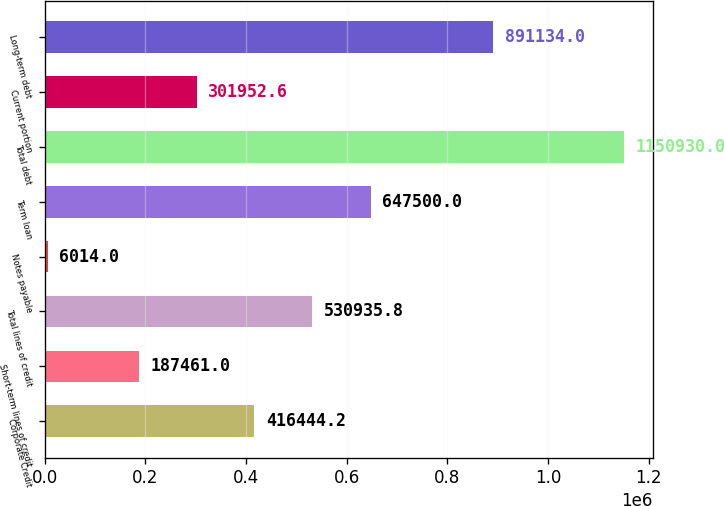Convert chart. <chart><loc_0><loc_0><loc_500><loc_500><bar_chart><fcel>Corporate Credit<fcel>Short-term lines of credit<fcel>Total lines of credit<fcel>Notes payable<fcel>Term loan<fcel>Total debt<fcel>Current portion<fcel>Long-term debt<nl><fcel>416444<fcel>187461<fcel>530936<fcel>6014<fcel>647500<fcel>1.15093e+06<fcel>301953<fcel>891134<nl></chart> 